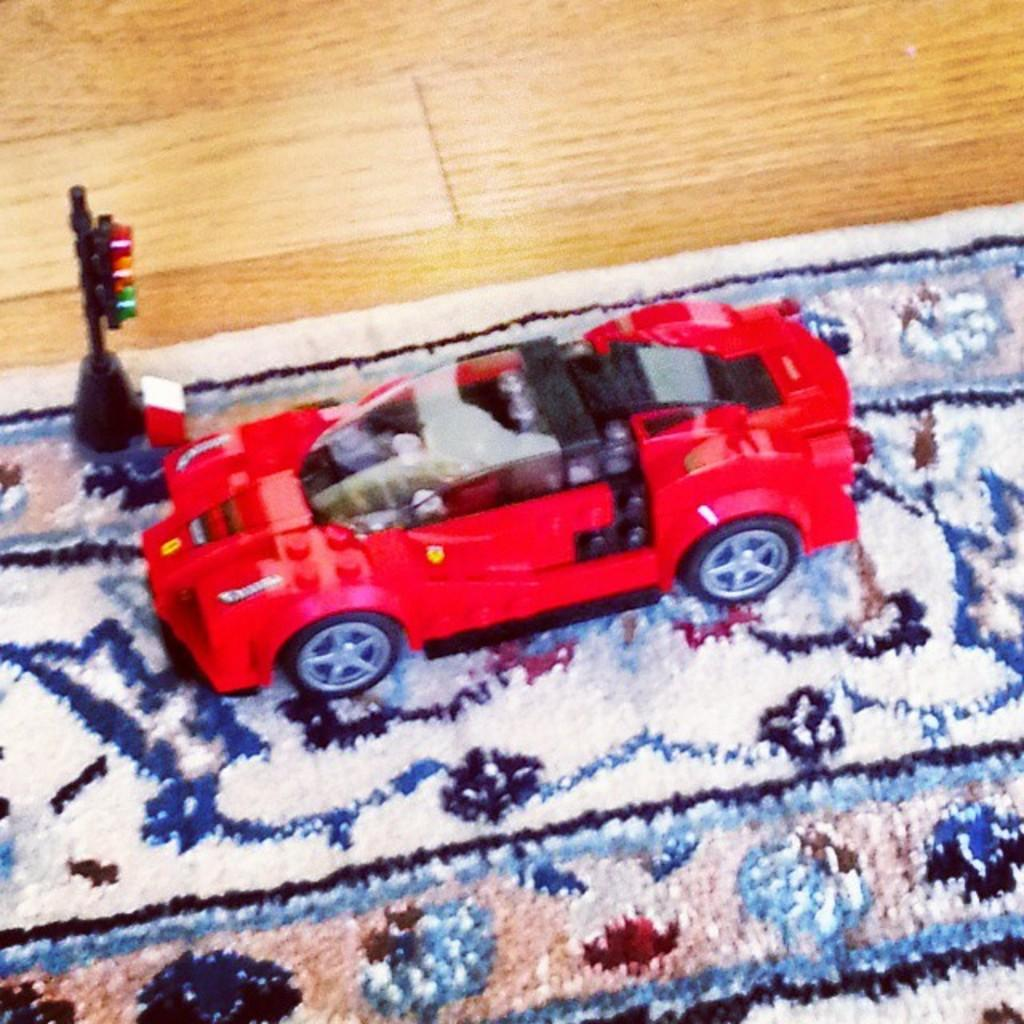What type of toy is present in the image? There is a toy car in the image. What other objects can be seen in the image? There are signal lights in the image. Where are the toy car and signal lights located? The toy car and signal lights are on a carpet. Can you tell me the date on the calendar in the image? There is no calendar present in the image; it only features a toy car and signal lights on a carpet. 